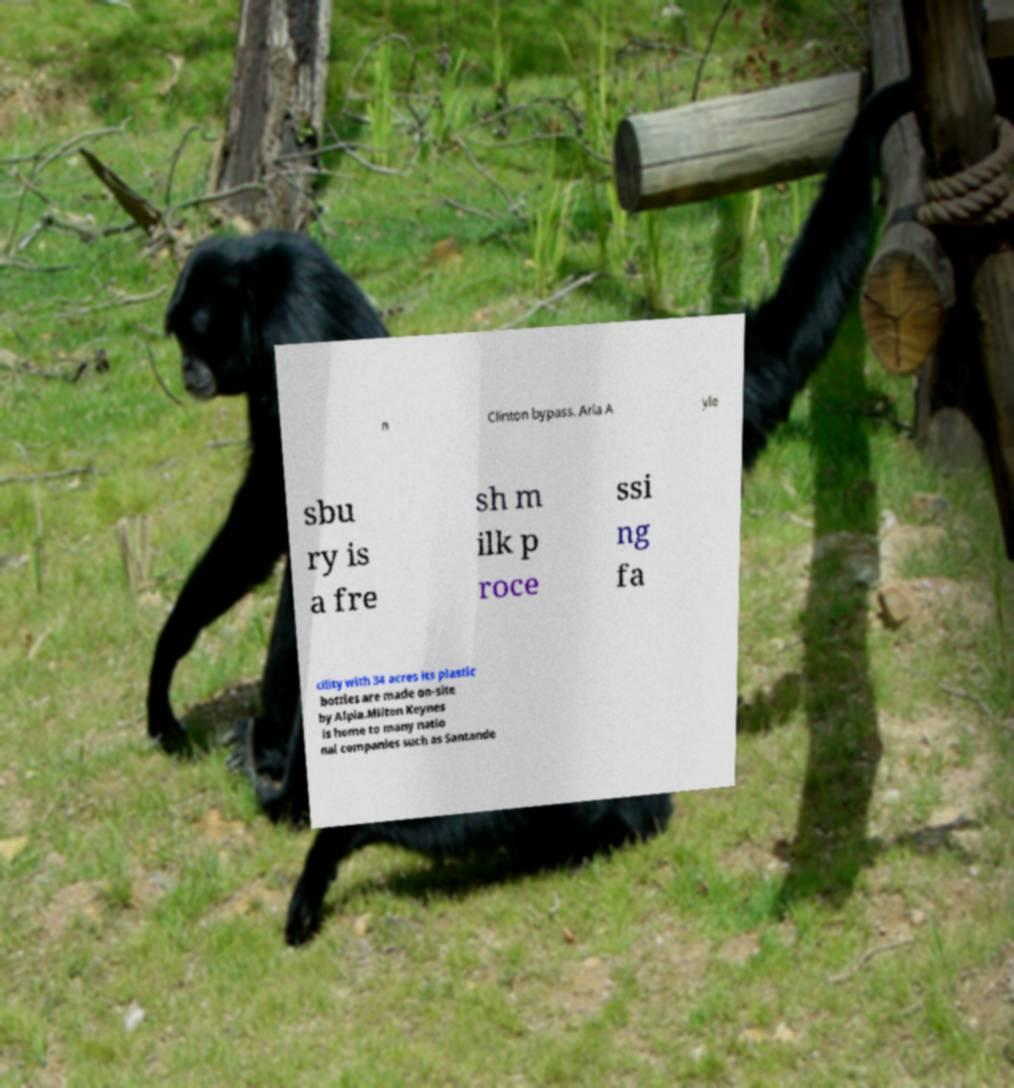Please read and relay the text visible in this image. What does it say? n Clinton bypass. Arla A yle sbu ry is a fre sh m ilk p roce ssi ng fa cility with 34 acres its plastic bottles are made on-site by Alpla.Milton Keynes is home to many natio nal companies such as Santande 